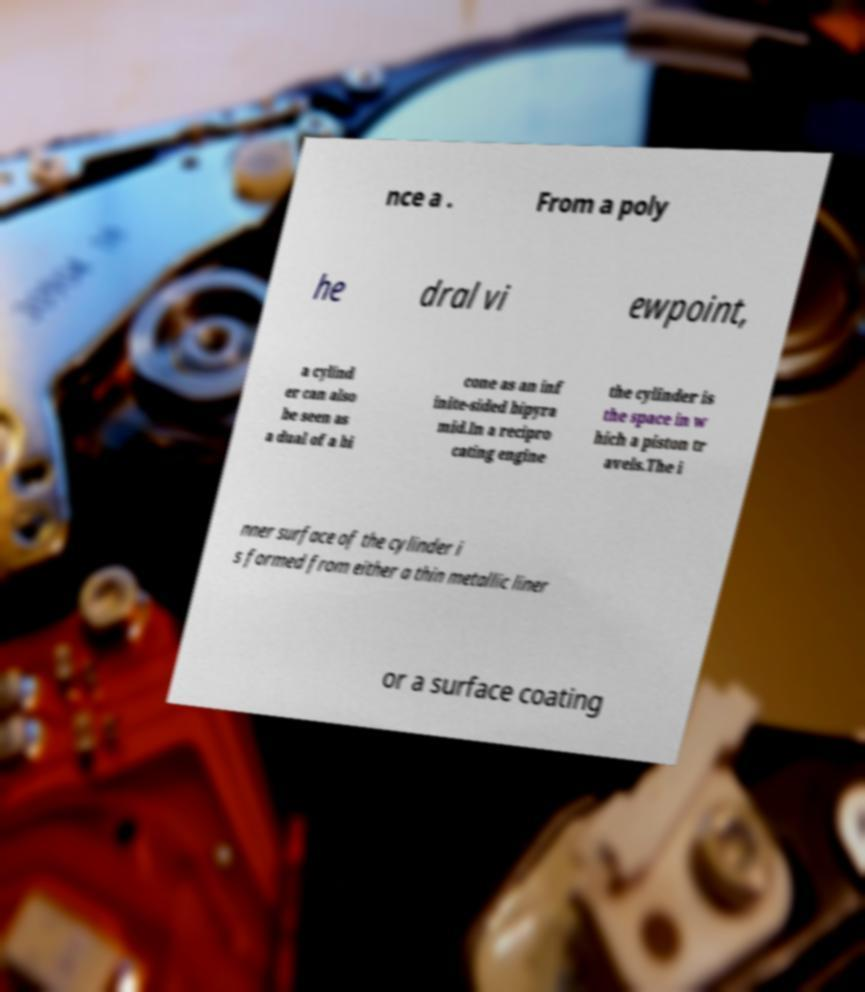Can you read and provide the text displayed in the image?This photo seems to have some interesting text. Can you extract and type it out for me? nce a . From a poly he dral vi ewpoint, a cylind er can also be seen as a dual of a bi cone as an inf inite-sided bipyra mid.In a recipro cating engine the cylinder is the space in w hich a piston tr avels.The i nner surface of the cylinder i s formed from either a thin metallic liner or a surface coating 